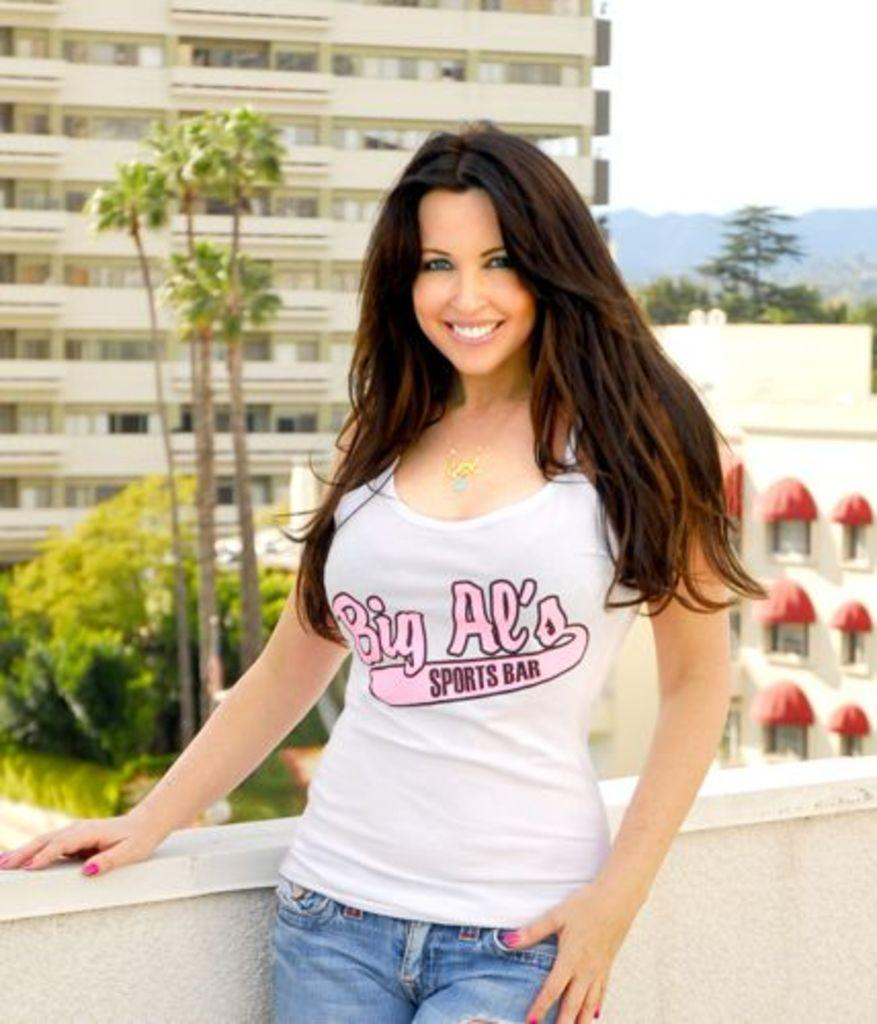Who is present in the image? There is a woman in the image. What is the woman wearing? The woman is wearing a white t-shirt and jeans. What can be seen in the background of the image? There are trees and buildings in the background of the image. What type of food is the woman holding in the image? There is no food visible in the image; the woman is not holding any food. Can you tell me how many ducks are present in the image? There are no ducks present in the image. 